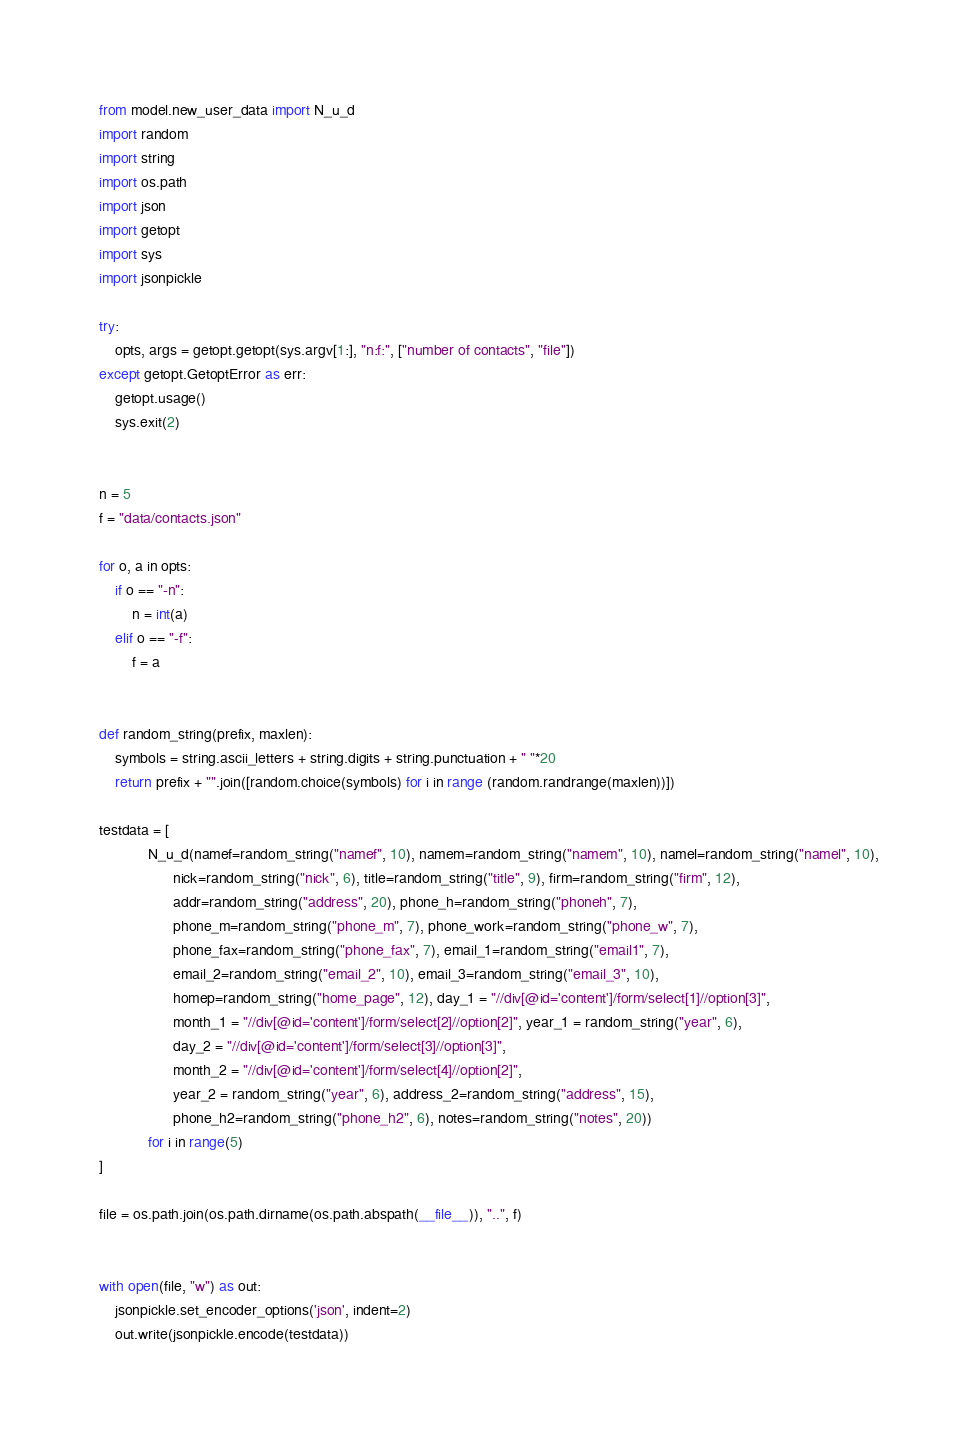Convert code to text. <code><loc_0><loc_0><loc_500><loc_500><_Python_>from model.new_user_data import N_u_d
import random
import string
import os.path
import json
import getopt
import sys
import jsonpickle

try:
    opts, args = getopt.getopt(sys.argv[1:], "n:f:", ["number of contacts", "file"])
except getopt.GetoptError as err:
    getopt.usage()
    sys.exit(2)


n = 5
f = "data/contacts.json"

for o, a in opts:
    if o == "-n":
        n = int(a)
    elif o == "-f":
        f = a


def random_string(prefix, maxlen):
    symbols = string.ascii_letters + string.digits + string.punctuation + " "*20
    return prefix + "".join([random.choice(symbols) for i in range (random.randrange(maxlen))])

testdata = [
            N_u_d(namef=random_string("namef", 10), namem=random_string("namem", 10), namel=random_string("namel", 10),
                  nick=random_string("nick", 6), title=random_string("title", 9), firm=random_string("firm", 12),
                  addr=random_string("address", 20), phone_h=random_string("phoneh", 7),
                  phone_m=random_string("phone_m", 7), phone_work=random_string("phone_w", 7),
                  phone_fax=random_string("phone_fax", 7), email_1=random_string("email1", 7),
                  email_2=random_string("email_2", 10), email_3=random_string("email_3", 10),
                  homep=random_string("home_page", 12), day_1 = "//div[@id='content']/form/select[1]//option[3]",
                  month_1 = "//div[@id='content']/form/select[2]//option[2]", year_1 = random_string("year", 6),
                  day_2 = "//div[@id='content']/form/select[3]//option[3]",
                  month_2 = "//div[@id='content']/form/select[4]//option[2]",
                  year_2 = random_string("year", 6), address_2=random_string("address", 15),
                  phone_h2=random_string("phone_h2", 6), notes=random_string("notes", 20))
            for i in range(5)
]

file = os.path.join(os.path.dirname(os.path.abspath(__file__)), "..", f)


with open(file, "w") as out:
    jsonpickle.set_encoder_options('json', indent=2)
    out.write(jsonpickle.encode(testdata))
</code> 